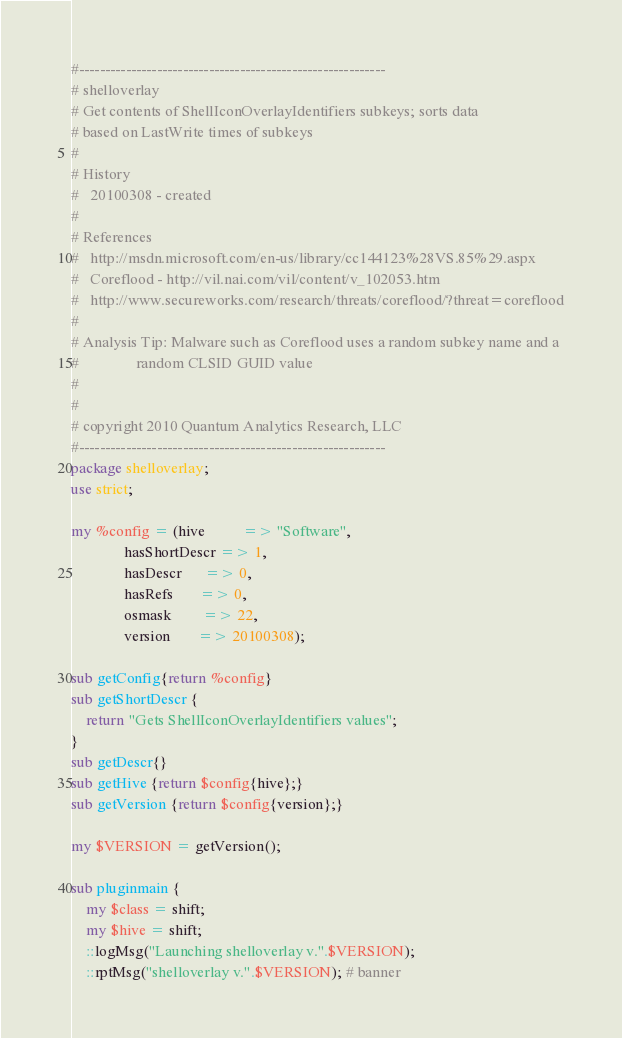<code> <loc_0><loc_0><loc_500><loc_500><_Perl_>#-----------------------------------------------------------
# shelloverlay
# Get contents of ShellIconOverlayIdentifiers subkeys; sorts data
# based on LastWrite times of subkeys
# 
# History
#   20100308 - created
#
# References
#   http://msdn.microsoft.com/en-us/library/cc144123%28VS.85%29.aspx
#   Coreflood - http://vil.nai.com/vil/content/v_102053.htm
#   http://www.secureworks.com/research/threats/coreflood/?threat=coreflood
#
# Analysis Tip: Malware such as Coreflood uses a random subkey name and a
#               random CLSID GUID value
#
#
# copyright 2010 Quantum Analytics Research, LLC
#-----------------------------------------------------------
package shelloverlay;
use strict;

my %config = (hive          => "Software",
              hasShortDescr => 1,
              hasDescr      => 0,
              hasRefs       => 0,
              osmask        => 22,
              version       => 20100308);

sub getConfig{return %config}
sub getShortDescr {
	return "Gets ShellIconOverlayIdentifiers values";	
}
sub getDescr{}
sub getHive {return $config{hive};}
sub getVersion {return $config{version};}

my $VERSION = getVersion();

sub pluginmain {
	my $class = shift;
	my $hive = shift;
	::logMsg("Launching shelloverlay v.".$VERSION);
	::rptMsg("shelloverlay v.".$VERSION); # banner</code> 